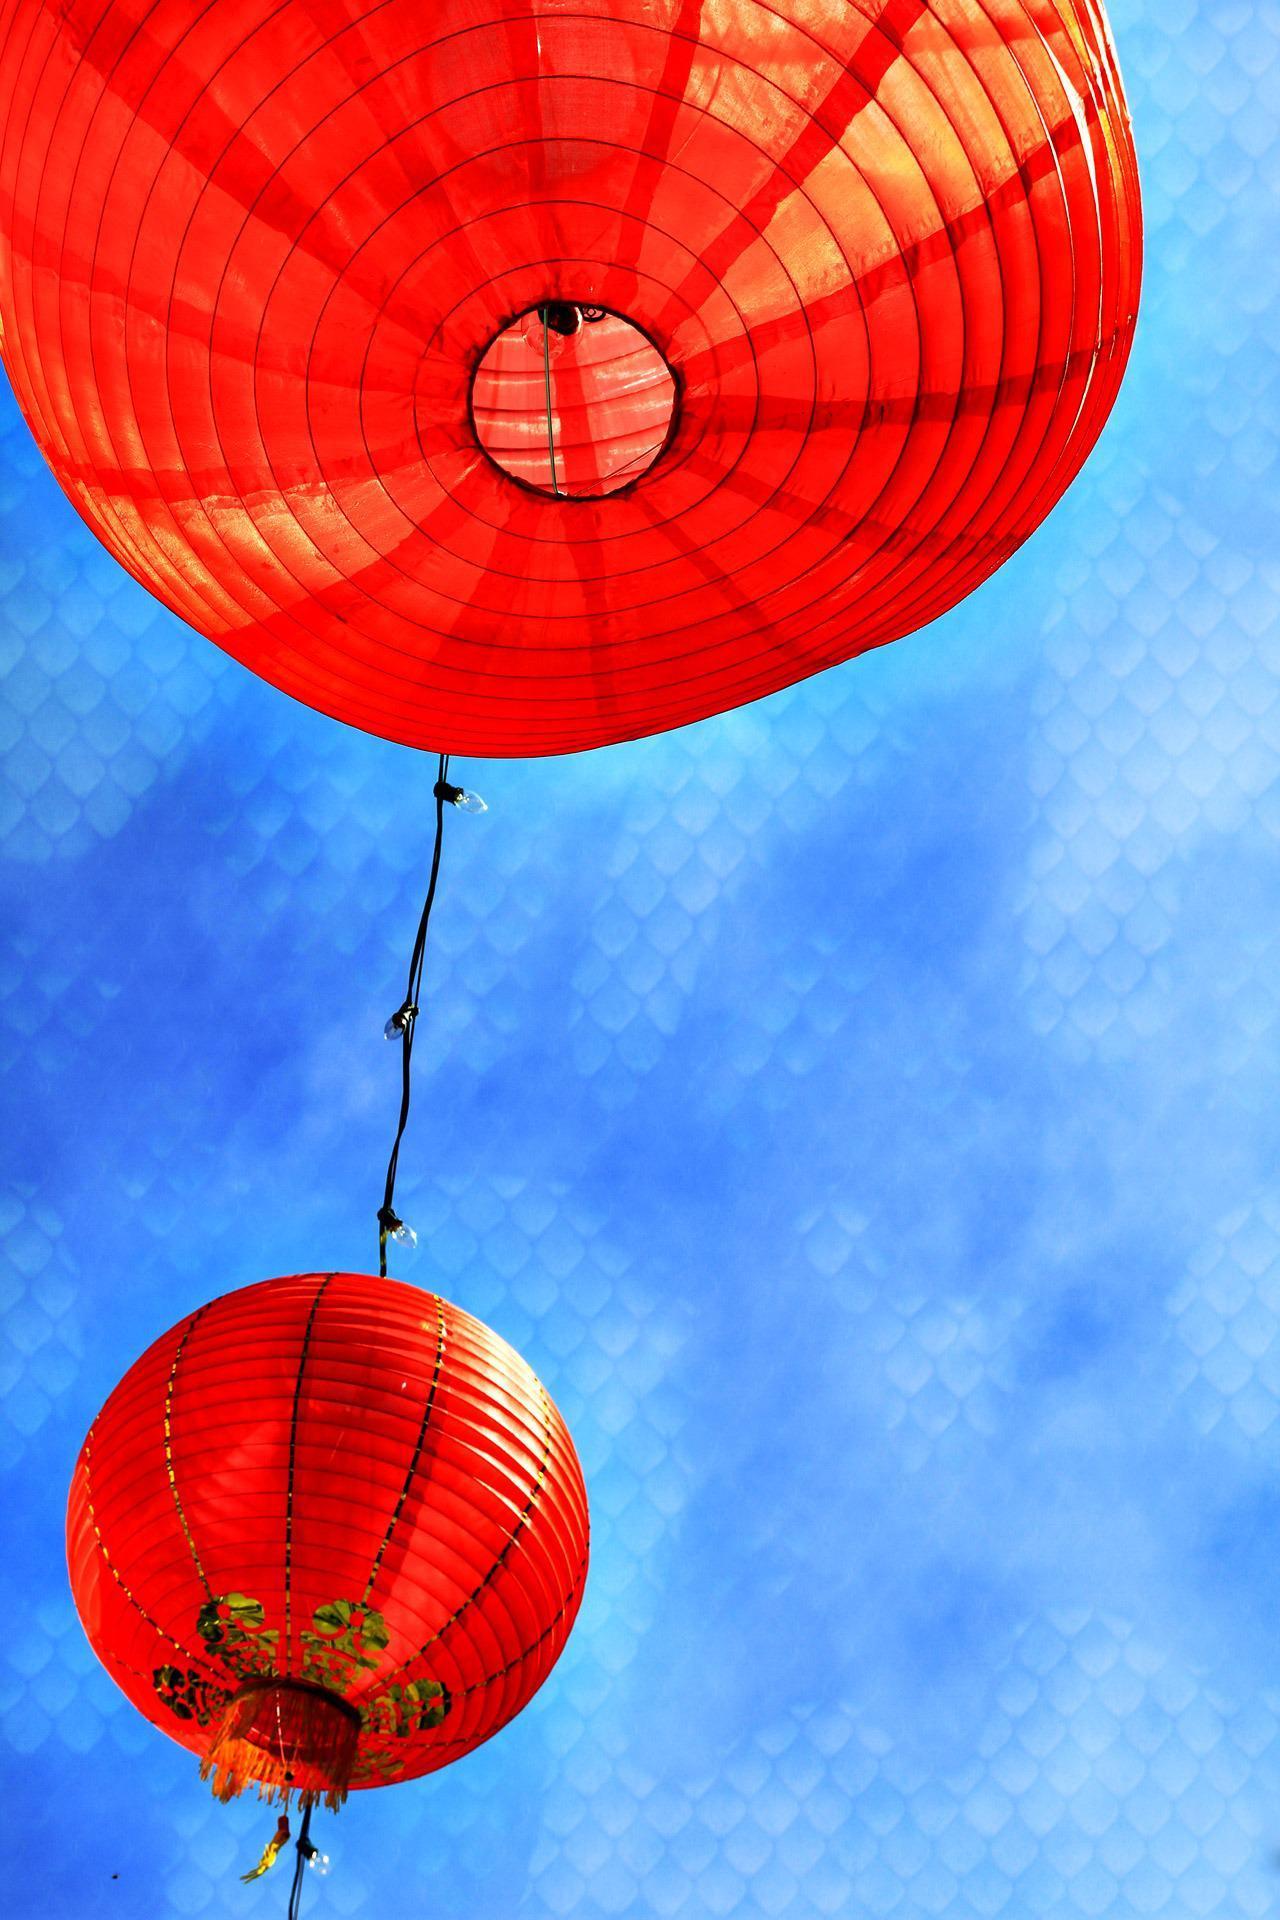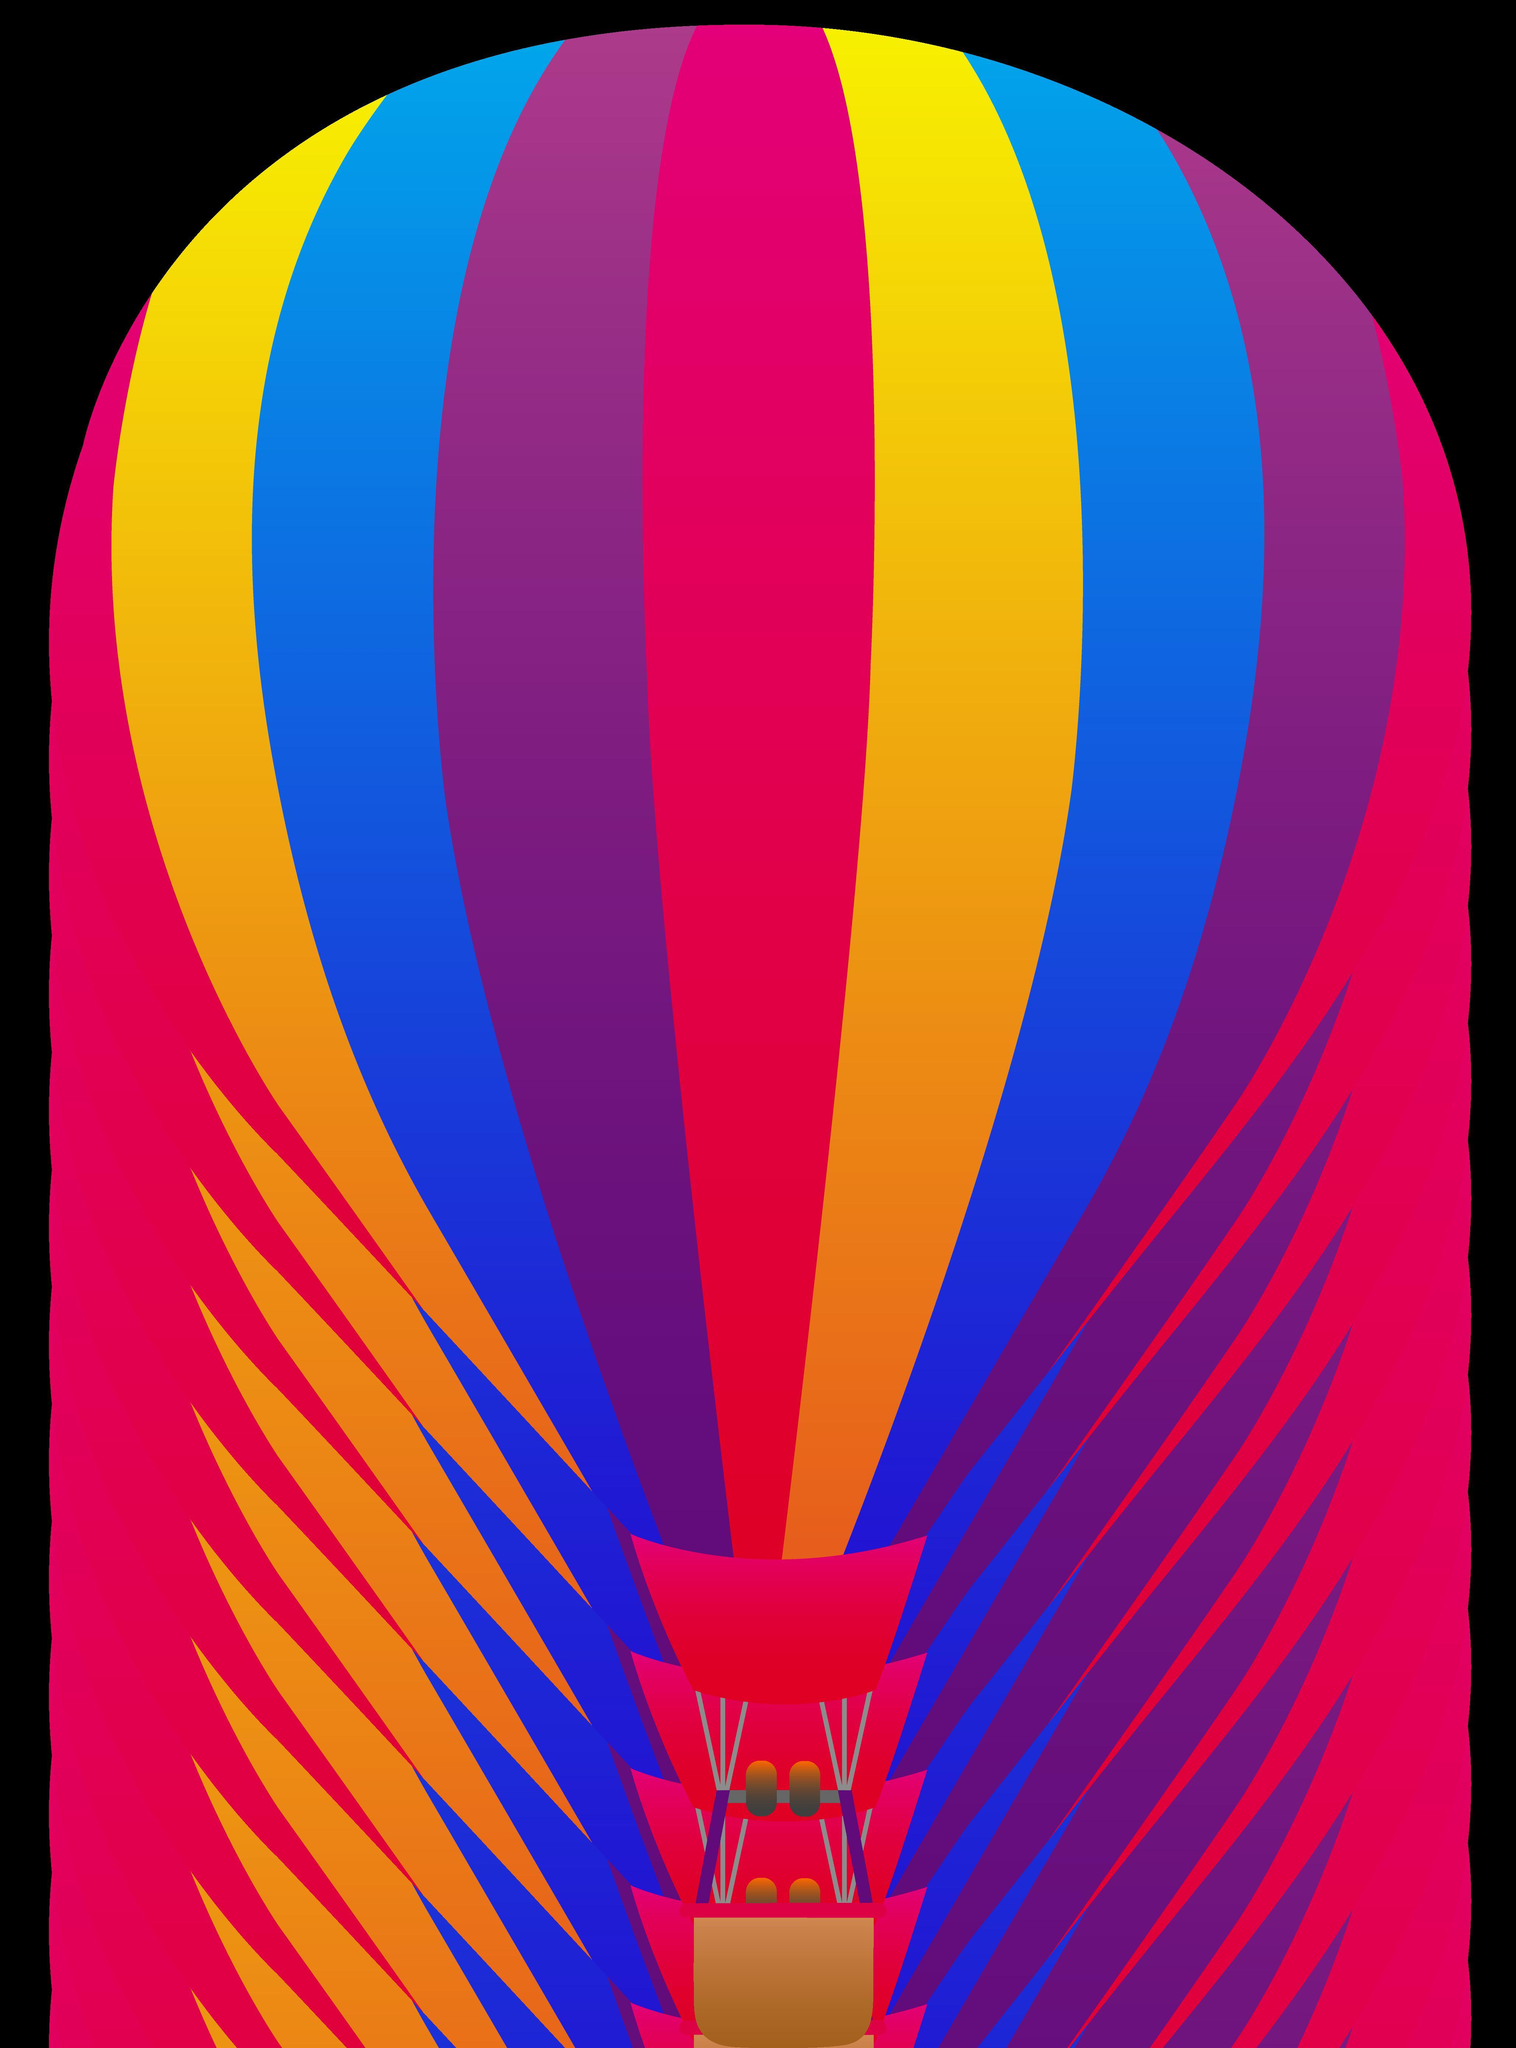The first image is the image on the left, the second image is the image on the right. Given the left and right images, does the statement "A total of two hot air balloons with wicker baskets attached below are shown against the sky." hold true? Answer yes or no. No. 